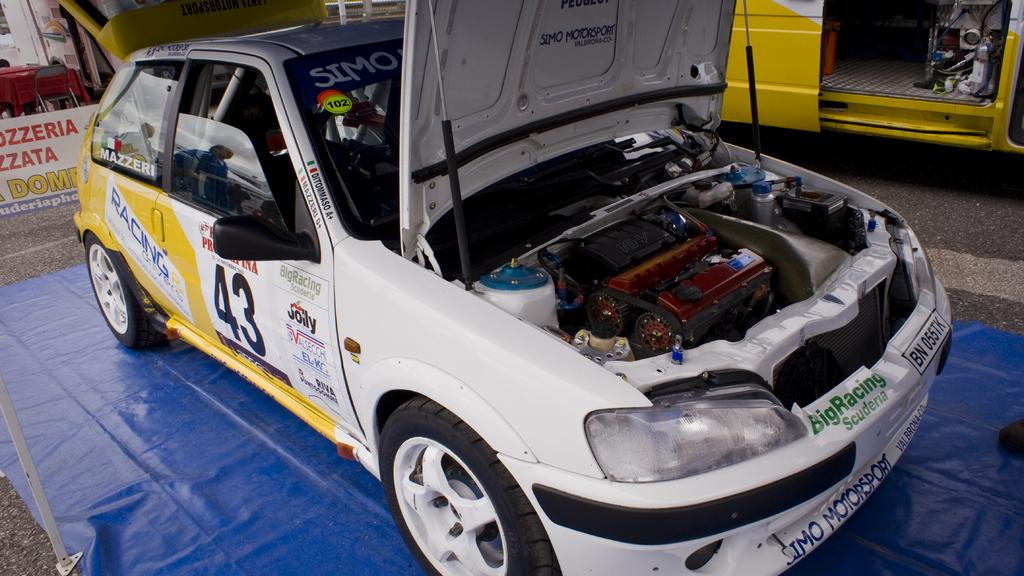What color is the car in the image? The car in the image is white. What type of floor covering is visible in the image? There is a blue color carpet on the floor in the image. Can you see any ghosts interacting with the car in the image? There are no ghosts present in the image. What type of paste is being used to clean the carpet in the image? There is no paste or cleaning activity depicted in the image; it only shows a white car and a blue carpet on the floor. 